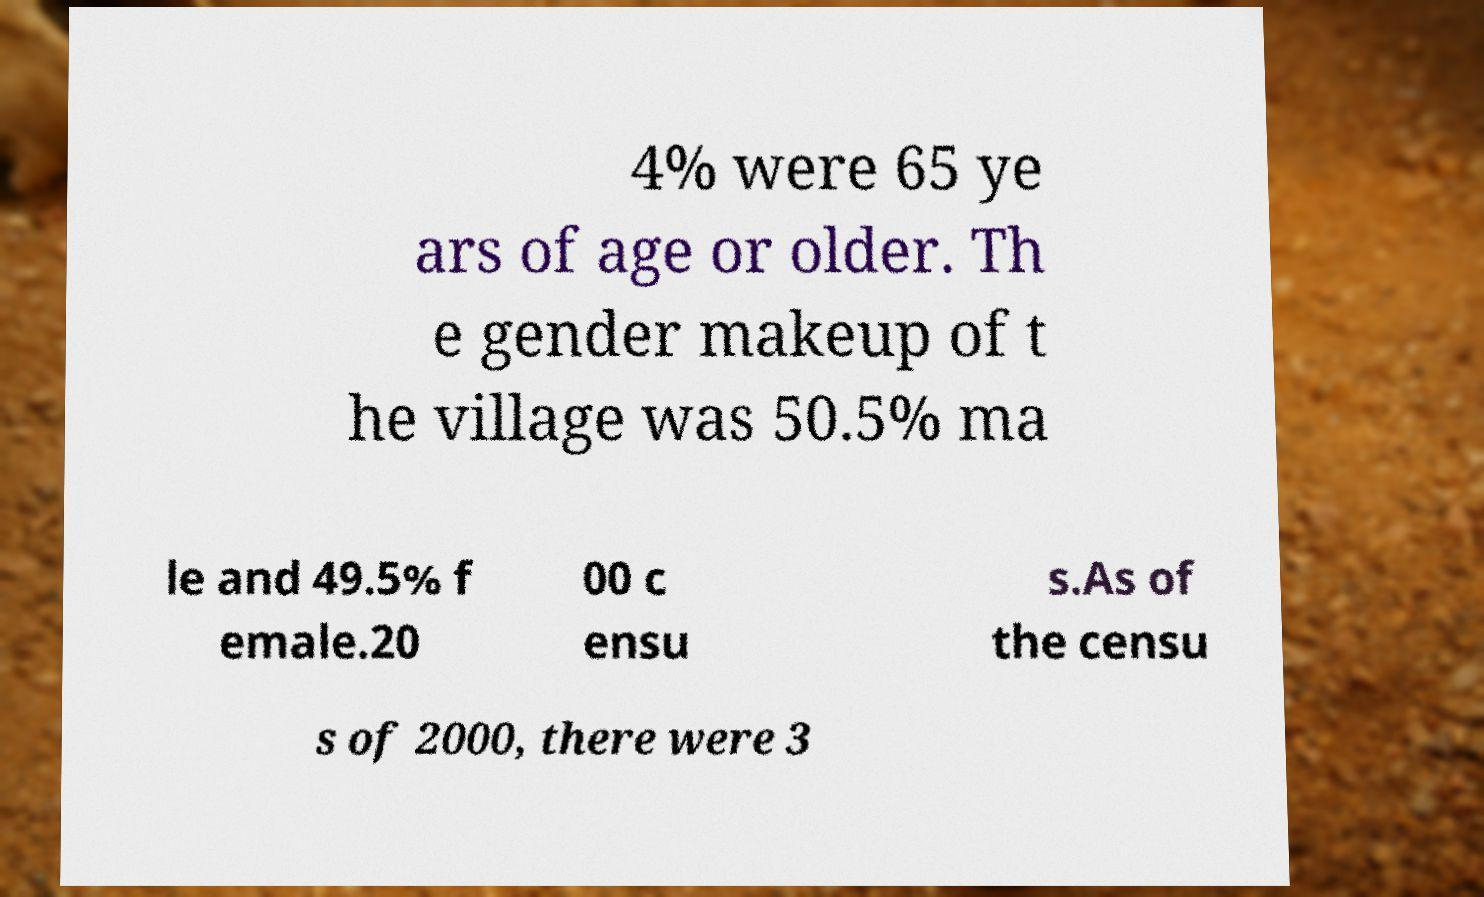Could you extract and type out the text from this image? 4% were 65 ye ars of age or older. Th e gender makeup of t he village was 50.5% ma le and 49.5% f emale.20 00 c ensu s.As of the censu s of 2000, there were 3 